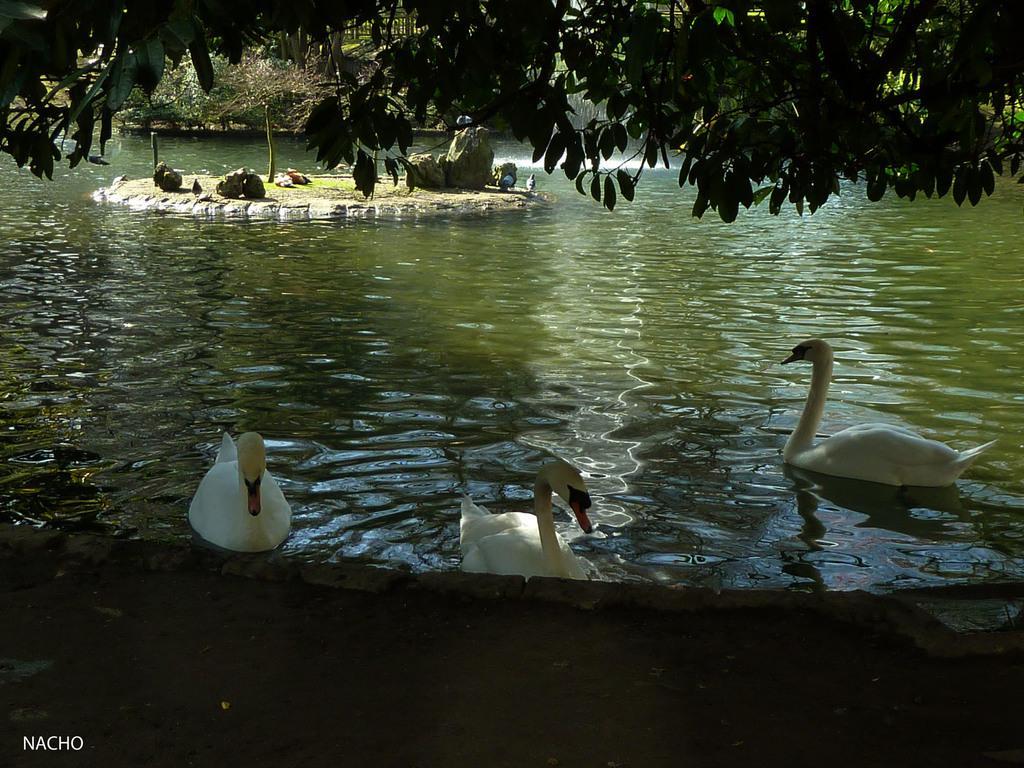Could you give a brief overview of what you see in this image? In this image, we can see trees, stones and there are birds on the water. At the bottom, there is some text. 